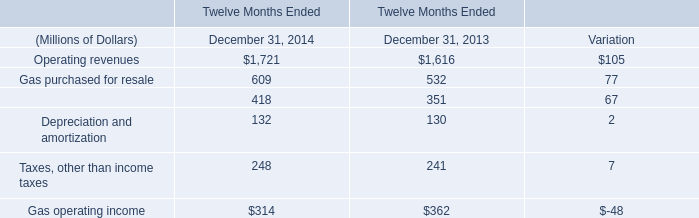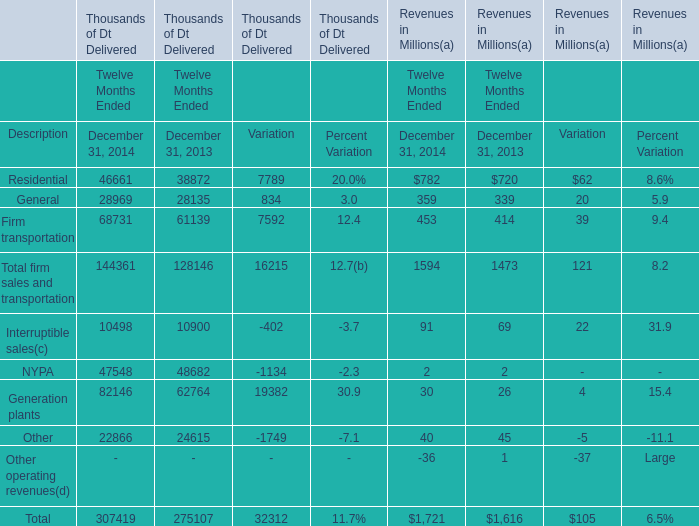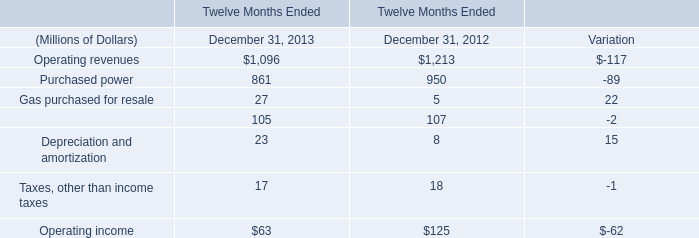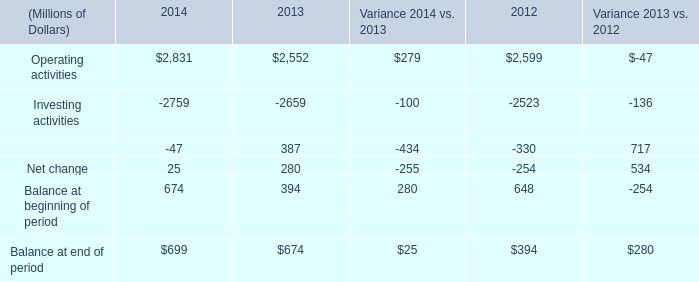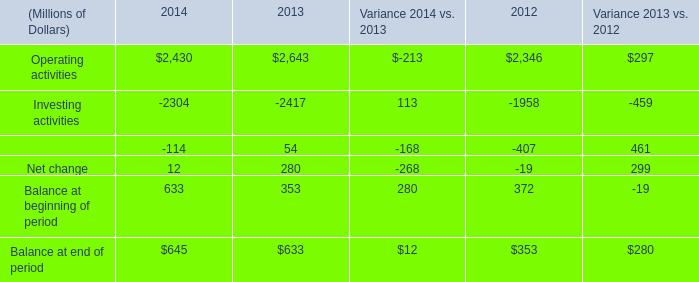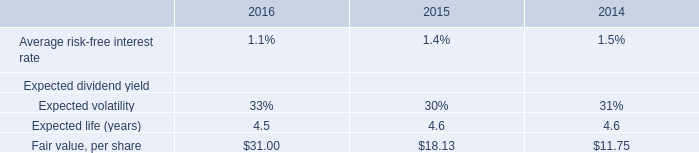What is the growing rate of Firm transportation in the years with the least General? 
Computations: ((68731 - 61139) / 61139)
Answer: 0.12418. 